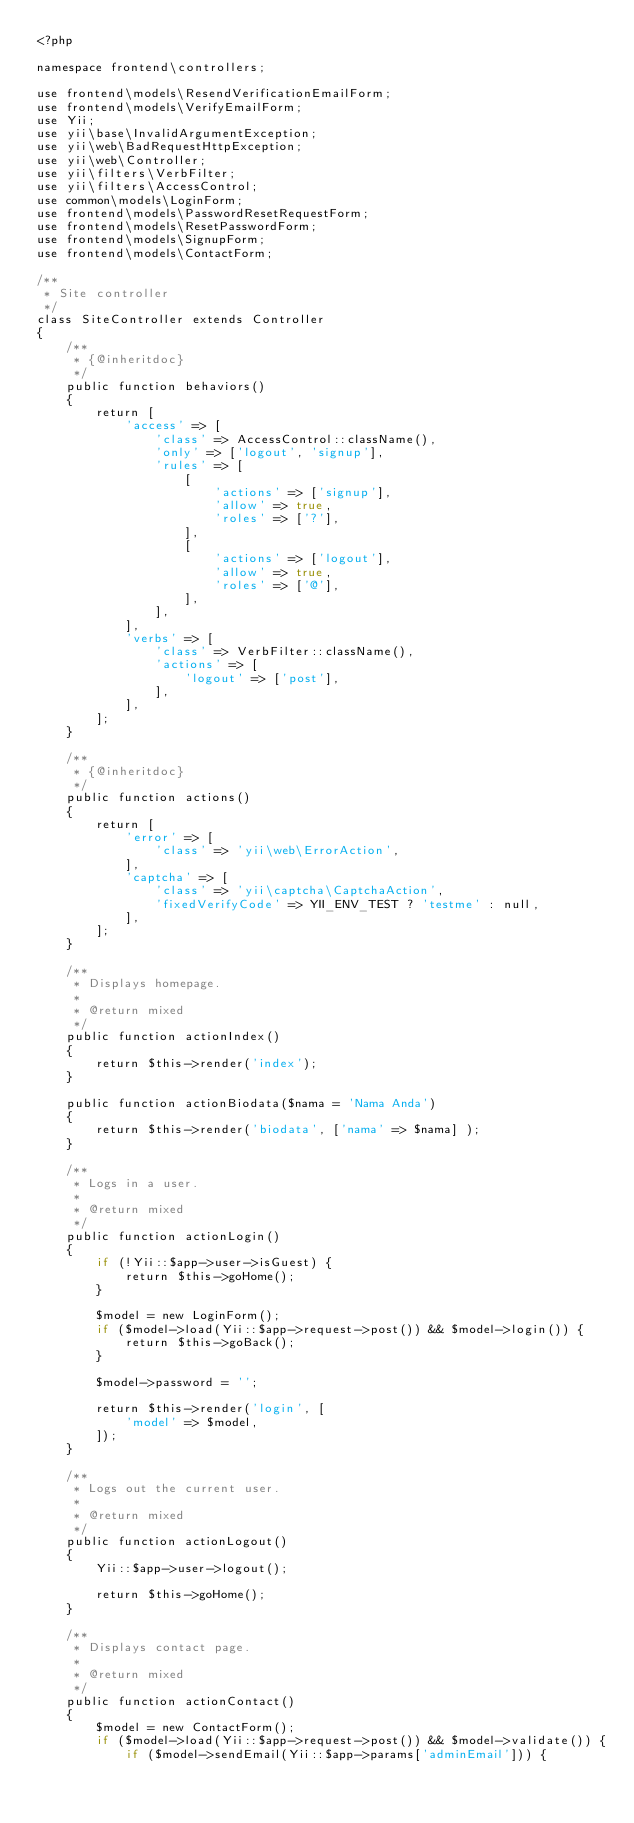Convert code to text. <code><loc_0><loc_0><loc_500><loc_500><_PHP_><?php

namespace frontend\controllers;

use frontend\models\ResendVerificationEmailForm;
use frontend\models\VerifyEmailForm;
use Yii;
use yii\base\InvalidArgumentException;
use yii\web\BadRequestHttpException;
use yii\web\Controller;
use yii\filters\VerbFilter;
use yii\filters\AccessControl;
use common\models\LoginForm;
use frontend\models\PasswordResetRequestForm;
use frontend\models\ResetPasswordForm;
use frontend\models\SignupForm;
use frontend\models\ContactForm;

/**
 * Site controller
 */
class SiteController extends Controller
{
    /**
     * {@inheritdoc}
     */
    public function behaviors()
    {
        return [
            'access' => [
                'class' => AccessControl::className(),
                'only' => ['logout', 'signup'],
                'rules' => [
                    [
                        'actions' => ['signup'],
                        'allow' => true,
                        'roles' => ['?'],
                    ],
                    [
                        'actions' => ['logout'],
                        'allow' => true,
                        'roles' => ['@'],
                    ],
                ],
            ],
            'verbs' => [
                'class' => VerbFilter::className(),
                'actions' => [
                    'logout' => ['post'],
                ],
            ],
        ];
    }

    /**
     * {@inheritdoc}
     */
    public function actions()
    {
        return [
            'error' => [
                'class' => 'yii\web\ErrorAction',
            ],
            'captcha' => [
                'class' => 'yii\captcha\CaptchaAction',
                'fixedVerifyCode' => YII_ENV_TEST ? 'testme' : null,
            ],
        ];
    }

    /**
     * Displays homepage.
     *
     * @return mixed
     */
    public function actionIndex()
    {
        return $this->render('index');
    }

    public function actionBiodata($nama = 'Nama Anda')
    {
        return $this->render('biodata', ['nama' => $nama] );
    }

    /**
     * Logs in a user.
     *
     * @return mixed
     */
    public function actionLogin()
    {
        if (!Yii::$app->user->isGuest) {
            return $this->goHome();
        }

        $model = new LoginForm();
        if ($model->load(Yii::$app->request->post()) && $model->login()) {
            return $this->goBack();
        }

        $model->password = '';

        return $this->render('login', [
            'model' => $model,
        ]);
    }

    /**
     * Logs out the current user.
     *
     * @return mixed
     */
    public function actionLogout()
    {
        Yii::$app->user->logout();

        return $this->goHome();
    }

    /**
     * Displays contact page.
     *
     * @return mixed
     */
    public function actionContact()
    {
        $model = new ContactForm();
        if ($model->load(Yii::$app->request->post()) && $model->validate()) {
            if ($model->sendEmail(Yii::$app->params['adminEmail'])) {</code> 